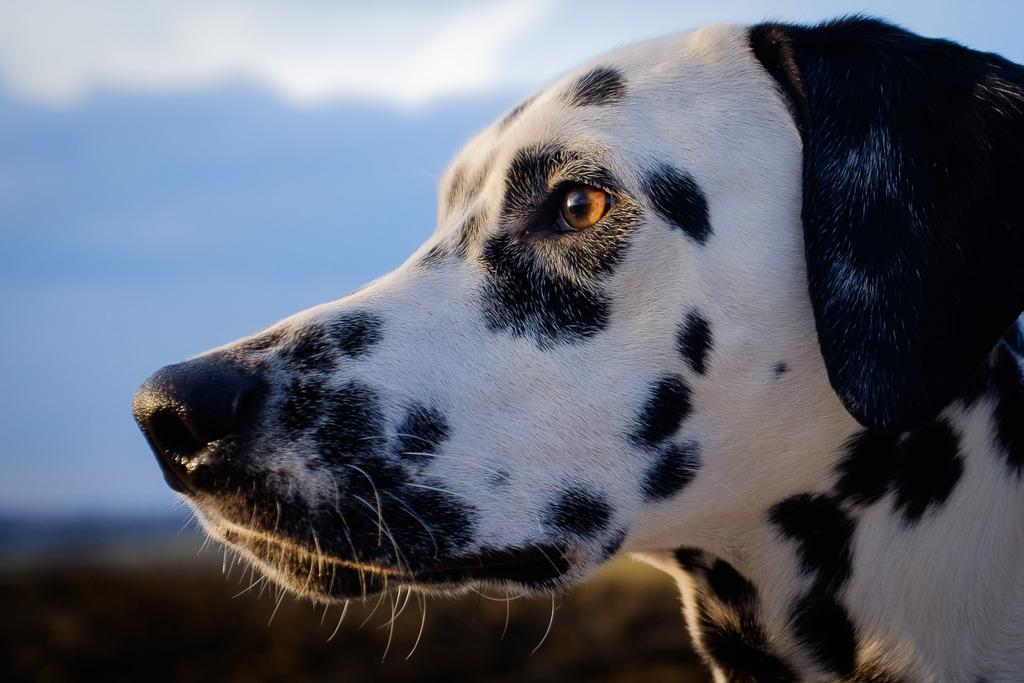What type of animal is present in the image? There is a dog in the image. Can you describe the background of the image? The background of the image is blurred. What part of the natural environment is visible in the image? The sky is visible in the image. What type of sponge is being used to clean the dog in the image? There is no sponge or cleaning activity present in the image. What type of competition is the dog participating in the image? There is no competition or activity involving the dog in the image. 